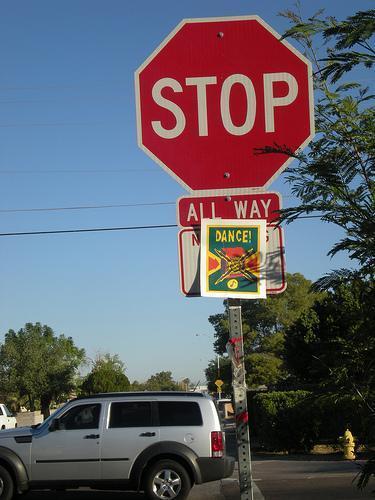How many tires or partial tires are shown?
Give a very brief answer. 2. 